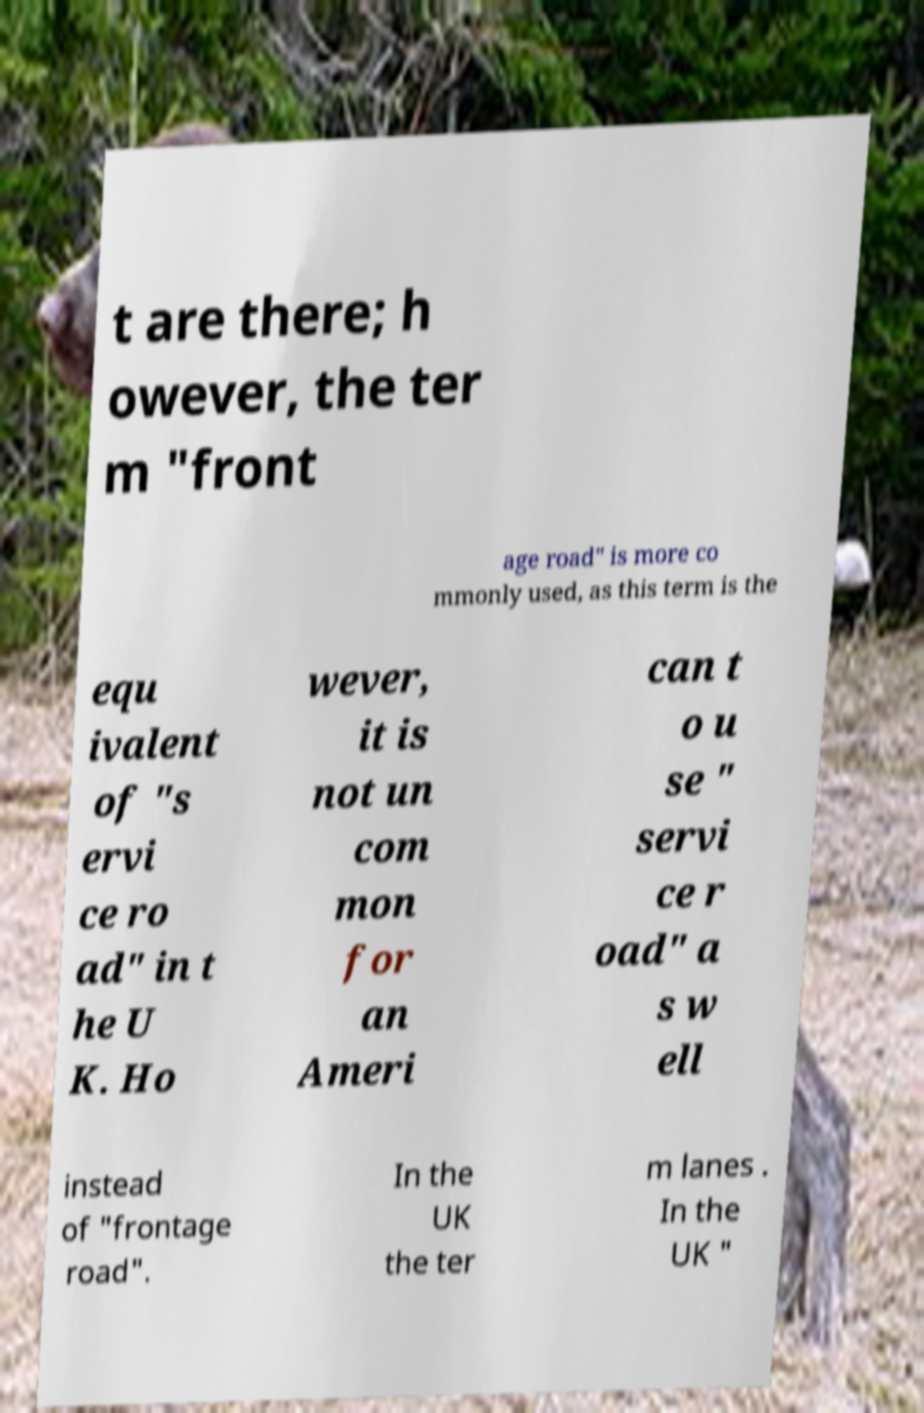Can you accurately transcribe the text from the provided image for me? t are there; h owever, the ter m "front age road" is more co mmonly used, as this term is the equ ivalent of "s ervi ce ro ad" in t he U K. Ho wever, it is not un com mon for an Ameri can t o u se " servi ce r oad" a s w ell instead of "frontage road". In the UK the ter m lanes . In the UK " 